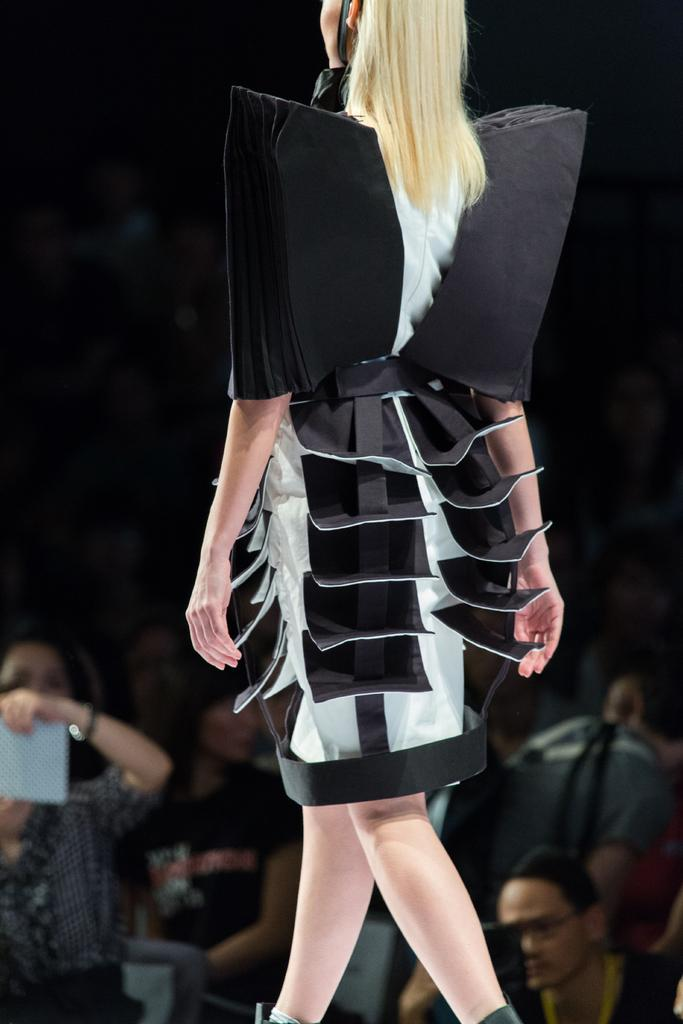Who is the main subject in the image? There is a woman in the image. What is the woman wearing? The woman is wearing a dress. What is the woman doing in the image? The woman is walking. What can be seen in the background of the image? There is an audience in the background of the image. What type of crown is the woman wearing in the image? There is no crown present in the image; the woman is wearing a dress. How does the watch affect the woman's walking in the image? There is no watch mentioned in the image, and therefore it cannot affect the woman's walking. 